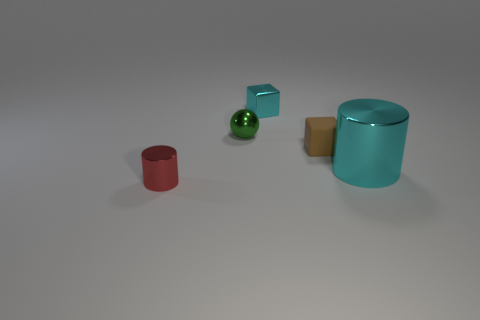Is the color of the large cylinder the same as the small metal cube?
Keep it short and to the point. Yes. Is there anything else that has the same material as the brown thing?
Your answer should be compact. No. How many cyan objects have the same shape as the green object?
Offer a very short reply. 0. There is a thing that is the same color as the tiny shiny block; what is it made of?
Offer a very short reply. Metal. What number of things are green rubber cylinders or cyan objects behind the tiny brown rubber block?
Make the answer very short. 1. What material is the tiny ball?
Offer a very short reply. Metal. What material is the other object that is the same shape as the red object?
Your answer should be very brief. Metal. What color is the object in front of the cylinder that is to the right of the tiny red cylinder?
Give a very brief answer. Red. How many rubber things are cylinders or tiny cylinders?
Your response must be concise. 0. Do the sphere and the big cyan thing have the same material?
Your answer should be compact. Yes. 